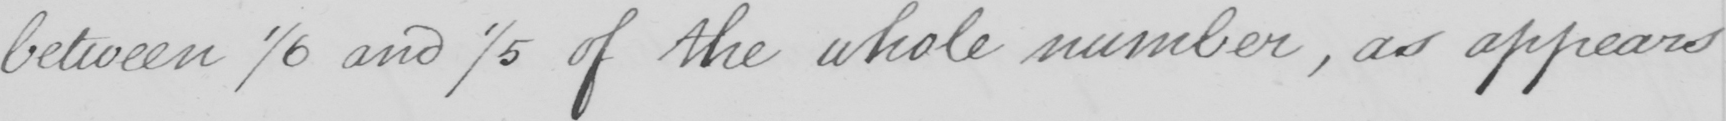Can you tell me what this handwritten text says? between 1/6 and 1/5 of the whole number , as appears 